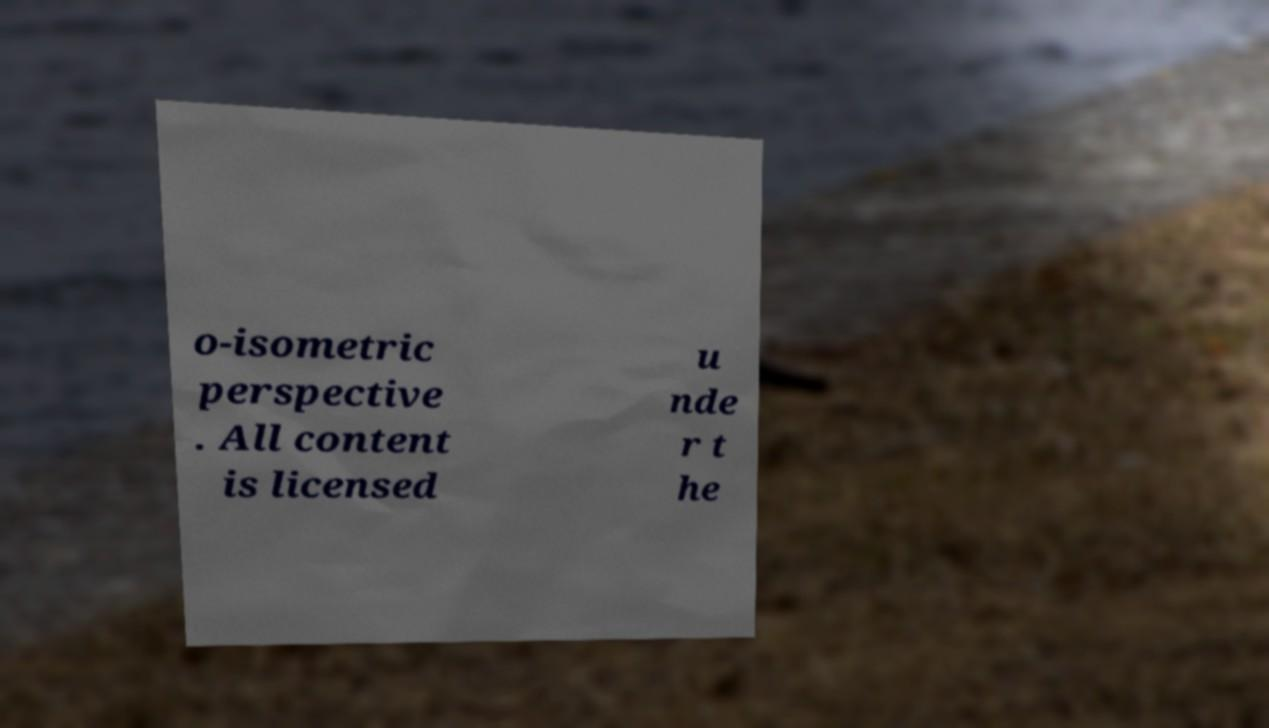Can you accurately transcribe the text from the provided image for me? o-isometric perspective . All content is licensed u nde r t he 